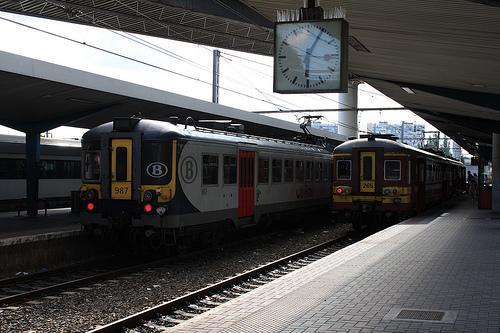How many trains are there?
Give a very brief answer. 2. 